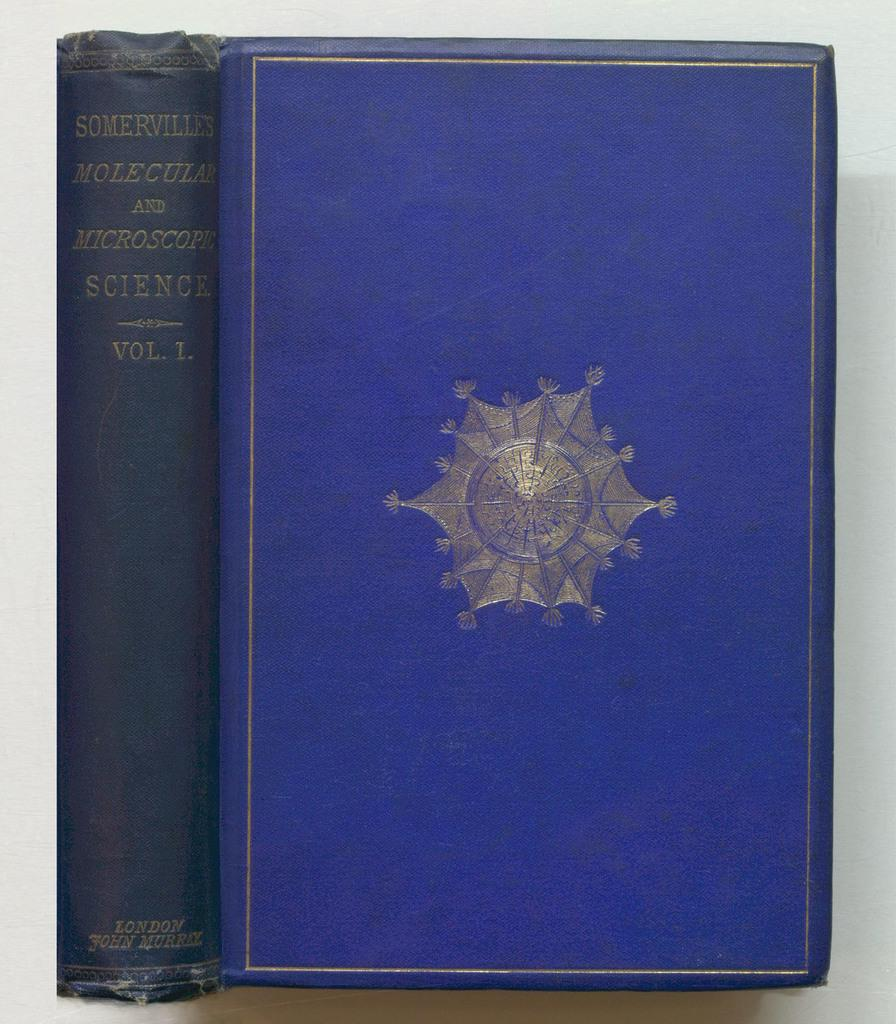What object can be seen in the image? There is a book in the image. What color is the background of the image? The background of the image is white. What can be found on the book in the image? There is text visible in the image. Is there a bike parked next to the book in the image? No, there is no bike present in the image. What type of lunch is being served on the book in the image? There is no lunch present in the image; it only features a book with text. 